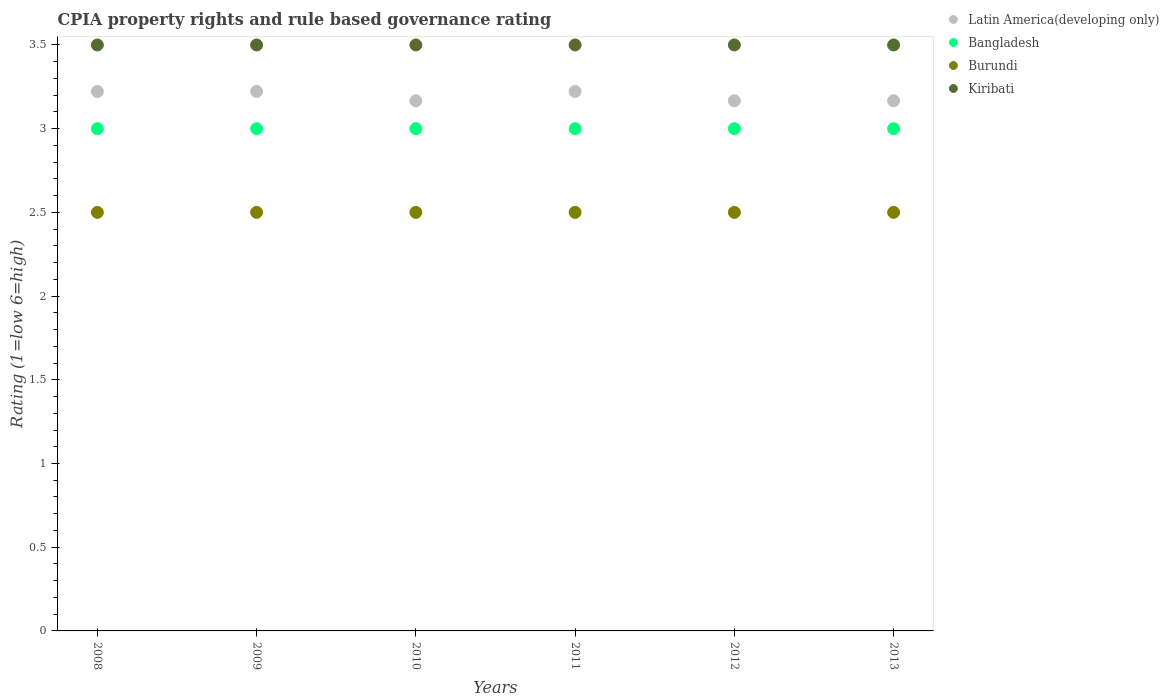Is the number of dotlines equal to the number of legend labels?
Ensure brevity in your answer.  Yes. Across all years, what is the maximum CPIA rating in Latin America(developing only)?
Your response must be concise. 3.22. Across all years, what is the minimum CPIA rating in Bangladesh?
Provide a short and direct response. 3. What is the difference between the CPIA rating in Latin America(developing only) in 2012 and that in 2013?
Provide a short and direct response. 0. What is the average CPIA rating in Latin America(developing only) per year?
Your answer should be very brief. 3.19. In the year 2010, what is the difference between the CPIA rating in Kiribati and CPIA rating in Latin America(developing only)?
Keep it short and to the point. 0.33. What is the ratio of the CPIA rating in Bangladesh in 2009 to that in 2011?
Make the answer very short. 1. Is the difference between the CPIA rating in Kiribati in 2011 and 2012 greater than the difference between the CPIA rating in Latin America(developing only) in 2011 and 2012?
Your answer should be compact. No. What is the difference between the highest and the second highest CPIA rating in Bangladesh?
Provide a short and direct response. 0. What is the difference between the highest and the lowest CPIA rating in Kiribati?
Offer a very short reply. 0. In how many years, is the CPIA rating in Bangladesh greater than the average CPIA rating in Bangladesh taken over all years?
Your answer should be compact. 0. Is the sum of the CPIA rating in Bangladesh in 2009 and 2012 greater than the maximum CPIA rating in Kiribati across all years?
Ensure brevity in your answer.  Yes. Does the CPIA rating in Kiribati monotonically increase over the years?
Make the answer very short. No. Is the CPIA rating in Burundi strictly less than the CPIA rating in Kiribati over the years?
Keep it short and to the point. Yes. How many years are there in the graph?
Your answer should be compact. 6. Does the graph contain any zero values?
Your answer should be compact. No. Where does the legend appear in the graph?
Offer a very short reply. Top right. How are the legend labels stacked?
Ensure brevity in your answer.  Vertical. What is the title of the graph?
Make the answer very short. CPIA property rights and rule based governance rating. What is the Rating (1=low 6=high) in Latin America(developing only) in 2008?
Provide a succinct answer. 3.22. What is the Rating (1=low 6=high) of Burundi in 2008?
Ensure brevity in your answer.  2.5. What is the Rating (1=low 6=high) in Latin America(developing only) in 2009?
Your response must be concise. 3.22. What is the Rating (1=low 6=high) in Burundi in 2009?
Keep it short and to the point. 2.5. What is the Rating (1=low 6=high) of Latin America(developing only) in 2010?
Make the answer very short. 3.17. What is the Rating (1=low 6=high) in Burundi in 2010?
Give a very brief answer. 2.5. What is the Rating (1=low 6=high) in Latin America(developing only) in 2011?
Your answer should be compact. 3.22. What is the Rating (1=low 6=high) of Bangladesh in 2011?
Make the answer very short. 3. What is the Rating (1=low 6=high) of Burundi in 2011?
Make the answer very short. 2.5. What is the Rating (1=low 6=high) of Kiribati in 2011?
Your answer should be very brief. 3.5. What is the Rating (1=low 6=high) in Latin America(developing only) in 2012?
Your response must be concise. 3.17. What is the Rating (1=low 6=high) in Latin America(developing only) in 2013?
Give a very brief answer. 3.17. What is the Rating (1=low 6=high) of Bangladesh in 2013?
Your response must be concise. 3. Across all years, what is the maximum Rating (1=low 6=high) in Latin America(developing only)?
Your answer should be very brief. 3.22. Across all years, what is the maximum Rating (1=low 6=high) of Kiribati?
Provide a short and direct response. 3.5. Across all years, what is the minimum Rating (1=low 6=high) in Latin America(developing only)?
Keep it short and to the point. 3.17. Across all years, what is the minimum Rating (1=low 6=high) of Bangladesh?
Offer a terse response. 3. Across all years, what is the minimum Rating (1=low 6=high) in Burundi?
Offer a terse response. 2.5. Across all years, what is the minimum Rating (1=low 6=high) in Kiribati?
Offer a terse response. 3.5. What is the total Rating (1=low 6=high) of Latin America(developing only) in the graph?
Provide a short and direct response. 19.17. What is the total Rating (1=low 6=high) in Bangladesh in the graph?
Keep it short and to the point. 18. What is the difference between the Rating (1=low 6=high) of Burundi in 2008 and that in 2009?
Your answer should be very brief. 0. What is the difference between the Rating (1=low 6=high) in Kiribati in 2008 and that in 2009?
Ensure brevity in your answer.  0. What is the difference between the Rating (1=low 6=high) of Latin America(developing only) in 2008 and that in 2010?
Your answer should be very brief. 0.06. What is the difference between the Rating (1=low 6=high) of Bangladesh in 2008 and that in 2010?
Your answer should be compact. 0. What is the difference between the Rating (1=low 6=high) of Kiribati in 2008 and that in 2010?
Offer a very short reply. 0. What is the difference between the Rating (1=low 6=high) of Latin America(developing only) in 2008 and that in 2011?
Provide a succinct answer. 0. What is the difference between the Rating (1=low 6=high) of Burundi in 2008 and that in 2011?
Your response must be concise. 0. What is the difference between the Rating (1=low 6=high) of Kiribati in 2008 and that in 2011?
Give a very brief answer. 0. What is the difference between the Rating (1=low 6=high) in Latin America(developing only) in 2008 and that in 2012?
Keep it short and to the point. 0.06. What is the difference between the Rating (1=low 6=high) of Bangladesh in 2008 and that in 2012?
Ensure brevity in your answer.  0. What is the difference between the Rating (1=low 6=high) in Latin America(developing only) in 2008 and that in 2013?
Provide a short and direct response. 0.06. What is the difference between the Rating (1=low 6=high) in Latin America(developing only) in 2009 and that in 2010?
Make the answer very short. 0.06. What is the difference between the Rating (1=low 6=high) of Burundi in 2009 and that in 2010?
Provide a succinct answer. 0. What is the difference between the Rating (1=low 6=high) of Latin America(developing only) in 2009 and that in 2011?
Provide a succinct answer. 0. What is the difference between the Rating (1=low 6=high) in Latin America(developing only) in 2009 and that in 2012?
Provide a short and direct response. 0.06. What is the difference between the Rating (1=low 6=high) of Latin America(developing only) in 2009 and that in 2013?
Offer a very short reply. 0.06. What is the difference between the Rating (1=low 6=high) in Bangladesh in 2009 and that in 2013?
Offer a terse response. 0. What is the difference between the Rating (1=low 6=high) in Latin America(developing only) in 2010 and that in 2011?
Offer a very short reply. -0.06. What is the difference between the Rating (1=low 6=high) of Latin America(developing only) in 2010 and that in 2012?
Keep it short and to the point. 0. What is the difference between the Rating (1=low 6=high) in Bangladesh in 2010 and that in 2012?
Provide a succinct answer. 0. What is the difference between the Rating (1=low 6=high) of Burundi in 2010 and that in 2012?
Your response must be concise. 0. What is the difference between the Rating (1=low 6=high) of Kiribati in 2010 and that in 2012?
Make the answer very short. 0. What is the difference between the Rating (1=low 6=high) in Latin America(developing only) in 2010 and that in 2013?
Offer a terse response. 0. What is the difference between the Rating (1=low 6=high) of Bangladesh in 2010 and that in 2013?
Give a very brief answer. 0. What is the difference between the Rating (1=low 6=high) of Latin America(developing only) in 2011 and that in 2012?
Keep it short and to the point. 0.06. What is the difference between the Rating (1=low 6=high) of Burundi in 2011 and that in 2012?
Offer a very short reply. 0. What is the difference between the Rating (1=low 6=high) in Kiribati in 2011 and that in 2012?
Give a very brief answer. 0. What is the difference between the Rating (1=low 6=high) in Latin America(developing only) in 2011 and that in 2013?
Make the answer very short. 0.06. What is the difference between the Rating (1=low 6=high) of Bangladesh in 2011 and that in 2013?
Your response must be concise. 0. What is the difference between the Rating (1=low 6=high) of Burundi in 2011 and that in 2013?
Offer a very short reply. 0. What is the difference between the Rating (1=low 6=high) in Latin America(developing only) in 2012 and that in 2013?
Give a very brief answer. 0. What is the difference between the Rating (1=low 6=high) in Burundi in 2012 and that in 2013?
Give a very brief answer. 0. What is the difference between the Rating (1=low 6=high) of Kiribati in 2012 and that in 2013?
Make the answer very short. 0. What is the difference between the Rating (1=low 6=high) in Latin America(developing only) in 2008 and the Rating (1=low 6=high) in Bangladesh in 2009?
Ensure brevity in your answer.  0.22. What is the difference between the Rating (1=low 6=high) in Latin America(developing only) in 2008 and the Rating (1=low 6=high) in Burundi in 2009?
Your answer should be compact. 0.72. What is the difference between the Rating (1=low 6=high) in Latin America(developing only) in 2008 and the Rating (1=low 6=high) in Kiribati in 2009?
Give a very brief answer. -0.28. What is the difference between the Rating (1=low 6=high) in Bangladesh in 2008 and the Rating (1=low 6=high) in Kiribati in 2009?
Make the answer very short. -0.5. What is the difference between the Rating (1=low 6=high) in Burundi in 2008 and the Rating (1=low 6=high) in Kiribati in 2009?
Your response must be concise. -1. What is the difference between the Rating (1=low 6=high) in Latin America(developing only) in 2008 and the Rating (1=low 6=high) in Bangladesh in 2010?
Provide a succinct answer. 0.22. What is the difference between the Rating (1=low 6=high) in Latin America(developing only) in 2008 and the Rating (1=low 6=high) in Burundi in 2010?
Ensure brevity in your answer.  0.72. What is the difference between the Rating (1=low 6=high) of Latin America(developing only) in 2008 and the Rating (1=low 6=high) of Kiribati in 2010?
Keep it short and to the point. -0.28. What is the difference between the Rating (1=low 6=high) of Bangladesh in 2008 and the Rating (1=low 6=high) of Burundi in 2010?
Make the answer very short. 0.5. What is the difference between the Rating (1=low 6=high) of Burundi in 2008 and the Rating (1=low 6=high) of Kiribati in 2010?
Ensure brevity in your answer.  -1. What is the difference between the Rating (1=low 6=high) of Latin America(developing only) in 2008 and the Rating (1=low 6=high) of Bangladesh in 2011?
Provide a short and direct response. 0.22. What is the difference between the Rating (1=low 6=high) in Latin America(developing only) in 2008 and the Rating (1=low 6=high) in Burundi in 2011?
Your answer should be compact. 0.72. What is the difference between the Rating (1=low 6=high) in Latin America(developing only) in 2008 and the Rating (1=low 6=high) in Kiribati in 2011?
Offer a very short reply. -0.28. What is the difference between the Rating (1=low 6=high) in Latin America(developing only) in 2008 and the Rating (1=low 6=high) in Bangladesh in 2012?
Provide a succinct answer. 0.22. What is the difference between the Rating (1=low 6=high) of Latin America(developing only) in 2008 and the Rating (1=low 6=high) of Burundi in 2012?
Your answer should be very brief. 0.72. What is the difference between the Rating (1=low 6=high) in Latin America(developing only) in 2008 and the Rating (1=low 6=high) in Kiribati in 2012?
Give a very brief answer. -0.28. What is the difference between the Rating (1=low 6=high) in Bangladesh in 2008 and the Rating (1=low 6=high) in Kiribati in 2012?
Make the answer very short. -0.5. What is the difference between the Rating (1=low 6=high) of Burundi in 2008 and the Rating (1=low 6=high) of Kiribati in 2012?
Keep it short and to the point. -1. What is the difference between the Rating (1=low 6=high) in Latin America(developing only) in 2008 and the Rating (1=low 6=high) in Bangladesh in 2013?
Offer a very short reply. 0.22. What is the difference between the Rating (1=low 6=high) in Latin America(developing only) in 2008 and the Rating (1=low 6=high) in Burundi in 2013?
Your answer should be compact. 0.72. What is the difference between the Rating (1=low 6=high) of Latin America(developing only) in 2008 and the Rating (1=low 6=high) of Kiribati in 2013?
Provide a succinct answer. -0.28. What is the difference between the Rating (1=low 6=high) in Bangladesh in 2008 and the Rating (1=low 6=high) in Kiribati in 2013?
Provide a succinct answer. -0.5. What is the difference between the Rating (1=low 6=high) of Burundi in 2008 and the Rating (1=low 6=high) of Kiribati in 2013?
Keep it short and to the point. -1. What is the difference between the Rating (1=low 6=high) in Latin America(developing only) in 2009 and the Rating (1=low 6=high) in Bangladesh in 2010?
Your response must be concise. 0.22. What is the difference between the Rating (1=low 6=high) of Latin America(developing only) in 2009 and the Rating (1=low 6=high) of Burundi in 2010?
Offer a terse response. 0.72. What is the difference between the Rating (1=low 6=high) in Latin America(developing only) in 2009 and the Rating (1=low 6=high) in Kiribati in 2010?
Your answer should be compact. -0.28. What is the difference between the Rating (1=low 6=high) of Burundi in 2009 and the Rating (1=low 6=high) of Kiribati in 2010?
Provide a short and direct response. -1. What is the difference between the Rating (1=low 6=high) in Latin America(developing only) in 2009 and the Rating (1=low 6=high) in Bangladesh in 2011?
Offer a very short reply. 0.22. What is the difference between the Rating (1=low 6=high) of Latin America(developing only) in 2009 and the Rating (1=low 6=high) of Burundi in 2011?
Provide a short and direct response. 0.72. What is the difference between the Rating (1=low 6=high) of Latin America(developing only) in 2009 and the Rating (1=low 6=high) of Kiribati in 2011?
Provide a succinct answer. -0.28. What is the difference between the Rating (1=low 6=high) in Bangladesh in 2009 and the Rating (1=low 6=high) in Kiribati in 2011?
Keep it short and to the point. -0.5. What is the difference between the Rating (1=low 6=high) of Burundi in 2009 and the Rating (1=low 6=high) of Kiribati in 2011?
Provide a succinct answer. -1. What is the difference between the Rating (1=low 6=high) in Latin America(developing only) in 2009 and the Rating (1=low 6=high) in Bangladesh in 2012?
Your answer should be compact. 0.22. What is the difference between the Rating (1=low 6=high) in Latin America(developing only) in 2009 and the Rating (1=low 6=high) in Burundi in 2012?
Offer a very short reply. 0.72. What is the difference between the Rating (1=low 6=high) of Latin America(developing only) in 2009 and the Rating (1=low 6=high) of Kiribati in 2012?
Provide a short and direct response. -0.28. What is the difference between the Rating (1=low 6=high) in Bangladesh in 2009 and the Rating (1=low 6=high) in Burundi in 2012?
Provide a short and direct response. 0.5. What is the difference between the Rating (1=low 6=high) of Latin America(developing only) in 2009 and the Rating (1=low 6=high) of Bangladesh in 2013?
Provide a succinct answer. 0.22. What is the difference between the Rating (1=low 6=high) in Latin America(developing only) in 2009 and the Rating (1=low 6=high) in Burundi in 2013?
Ensure brevity in your answer.  0.72. What is the difference between the Rating (1=low 6=high) in Latin America(developing only) in 2009 and the Rating (1=low 6=high) in Kiribati in 2013?
Provide a short and direct response. -0.28. What is the difference between the Rating (1=low 6=high) in Burundi in 2009 and the Rating (1=low 6=high) in Kiribati in 2013?
Offer a terse response. -1. What is the difference between the Rating (1=low 6=high) in Latin America(developing only) in 2010 and the Rating (1=low 6=high) in Bangladesh in 2011?
Offer a terse response. 0.17. What is the difference between the Rating (1=low 6=high) of Latin America(developing only) in 2010 and the Rating (1=low 6=high) of Burundi in 2011?
Your response must be concise. 0.67. What is the difference between the Rating (1=low 6=high) in Latin America(developing only) in 2010 and the Rating (1=low 6=high) in Kiribati in 2011?
Offer a very short reply. -0.33. What is the difference between the Rating (1=low 6=high) in Bangladesh in 2010 and the Rating (1=low 6=high) in Kiribati in 2011?
Your response must be concise. -0.5. What is the difference between the Rating (1=low 6=high) in Bangladesh in 2010 and the Rating (1=low 6=high) in Kiribati in 2012?
Make the answer very short. -0.5. What is the difference between the Rating (1=low 6=high) in Latin America(developing only) in 2010 and the Rating (1=low 6=high) in Burundi in 2013?
Your answer should be compact. 0.67. What is the difference between the Rating (1=low 6=high) of Latin America(developing only) in 2010 and the Rating (1=low 6=high) of Kiribati in 2013?
Keep it short and to the point. -0.33. What is the difference between the Rating (1=low 6=high) of Bangladesh in 2010 and the Rating (1=low 6=high) of Kiribati in 2013?
Your answer should be very brief. -0.5. What is the difference between the Rating (1=low 6=high) in Burundi in 2010 and the Rating (1=low 6=high) in Kiribati in 2013?
Your answer should be very brief. -1. What is the difference between the Rating (1=low 6=high) in Latin America(developing only) in 2011 and the Rating (1=low 6=high) in Bangladesh in 2012?
Keep it short and to the point. 0.22. What is the difference between the Rating (1=low 6=high) of Latin America(developing only) in 2011 and the Rating (1=low 6=high) of Burundi in 2012?
Ensure brevity in your answer.  0.72. What is the difference between the Rating (1=low 6=high) in Latin America(developing only) in 2011 and the Rating (1=low 6=high) in Kiribati in 2012?
Provide a succinct answer. -0.28. What is the difference between the Rating (1=low 6=high) of Bangladesh in 2011 and the Rating (1=low 6=high) of Kiribati in 2012?
Provide a succinct answer. -0.5. What is the difference between the Rating (1=low 6=high) of Burundi in 2011 and the Rating (1=low 6=high) of Kiribati in 2012?
Provide a succinct answer. -1. What is the difference between the Rating (1=low 6=high) in Latin America(developing only) in 2011 and the Rating (1=low 6=high) in Bangladesh in 2013?
Keep it short and to the point. 0.22. What is the difference between the Rating (1=low 6=high) in Latin America(developing only) in 2011 and the Rating (1=low 6=high) in Burundi in 2013?
Your answer should be very brief. 0.72. What is the difference between the Rating (1=low 6=high) in Latin America(developing only) in 2011 and the Rating (1=low 6=high) in Kiribati in 2013?
Offer a terse response. -0.28. What is the difference between the Rating (1=low 6=high) in Bangladesh in 2011 and the Rating (1=low 6=high) in Burundi in 2013?
Your answer should be very brief. 0.5. What is the difference between the Rating (1=low 6=high) of Bangladesh in 2011 and the Rating (1=low 6=high) of Kiribati in 2013?
Your answer should be compact. -0.5. What is the difference between the Rating (1=low 6=high) in Latin America(developing only) in 2012 and the Rating (1=low 6=high) in Burundi in 2013?
Give a very brief answer. 0.67. What is the difference between the Rating (1=low 6=high) in Bangladesh in 2012 and the Rating (1=low 6=high) in Kiribati in 2013?
Your response must be concise. -0.5. What is the average Rating (1=low 6=high) in Latin America(developing only) per year?
Keep it short and to the point. 3.19. What is the average Rating (1=low 6=high) of Burundi per year?
Give a very brief answer. 2.5. In the year 2008, what is the difference between the Rating (1=low 6=high) of Latin America(developing only) and Rating (1=low 6=high) of Bangladesh?
Provide a succinct answer. 0.22. In the year 2008, what is the difference between the Rating (1=low 6=high) in Latin America(developing only) and Rating (1=low 6=high) in Burundi?
Your response must be concise. 0.72. In the year 2008, what is the difference between the Rating (1=low 6=high) of Latin America(developing only) and Rating (1=low 6=high) of Kiribati?
Offer a terse response. -0.28. In the year 2008, what is the difference between the Rating (1=low 6=high) of Bangladesh and Rating (1=low 6=high) of Kiribati?
Provide a succinct answer. -0.5. In the year 2009, what is the difference between the Rating (1=low 6=high) in Latin America(developing only) and Rating (1=low 6=high) in Bangladesh?
Make the answer very short. 0.22. In the year 2009, what is the difference between the Rating (1=low 6=high) of Latin America(developing only) and Rating (1=low 6=high) of Burundi?
Provide a succinct answer. 0.72. In the year 2009, what is the difference between the Rating (1=low 6=high) in Latin America(developing only) and Rating (1=low 6=high) in Kiribati?
Your answer should be very brief. -0.28. In the year 2009, what is the difference between the Rating (1=low 6=high) of Bangladesh and Rating (1=low 6=high) of Kiribati?
Provide a succinct answer. -0.5. In the year 2009, what is the difference between the Rating (1=low 6=high) in Burundi and Rating (1=low 6=high) in Kiribati?
Provide a succinct answer. -1. In the year 2010, what is the difference between the Rating (1=low 6=high) in Latin America(developing only) and Rating (1=low 6=high) in Kiribati?
Offer a very short reply. -0.33. In the year 2011, what is the difference between the Rating (1=low 6=high) of Latin America(developing only) and Rating (1=low 6=high) of Bangladesh?
Provide a succinct answer. 0.22. In the year 2011, what is the difference between the Rating (1=low 6=high) of Latin America(developing only) and Rating (1=low 6=high) of Burundi?
Ensure brevity in your answer.  0.72. In the year 2011, what is the difference between the Rating (1=low 6=high) of Latin America(developing only) and Rating (1=low 6=high) of Kiribati?
Make the answer very short. -0.28. In the year 2011, what is the difference between the Rating (1=low 6=high) in Bangladesh and Rating (1=low 6=high) in Kiribati?
Provide a succinct answer. -0.5. In the year 2012, what is the difference between the Rating (1=low 6=high) of Latin America(developing only) and Rating (1=low 6=high) of Burundi?
Provide a succinct answer. 0.67. In the year 2012, what is the difference between the Rating (1=low 6=high) in Latin America(developing only) and Rating (1=low 6=high) in Kiribati?
Give a very brief answer. -0.33. In the year 2012, what is the difference between the Rating (1=low 6=high) of Bangladesh and Rating (1=low 6=high) of Burundi?
Offer a very short reply. 0.5. In the year 2012, what is the difference between the Rating (1=low 6=high) in Bangladesh and Rating (1=low 6=high) in Kiribati?
Your answer should be very brief. -0.5. In the year 2013, what is the difference between the Rating (1=low 6=high) of Latin America(developing only) and Rating (1=low 6=high) of Bangladesh?
Your response must be concise. 0.17. In the year 2013, what is the difference between the Rating (1=low 6=high) in Latin America(developing only) and Rating (1=low 6=high) in Burundi?
Offer a terse response. 0.67. What is the ratio of the Rating (1=low 6=high) of Latin America(developing only) in 2008 to that in 2009?
Provide a succinct answer. 1. What is the ratio of the Rating (1=low 6=high) in Bangladesh in 2008 to that in 2009?
Ensure brevity in your answer.  1. What is the ratio of the Rating (1=low 6=high) of Latin America(developing only) in 2008 to that in 2010?
Offer a very short reply. 1.02. What is the ratio of the Rating (1=low 6=high) in Bangladesh in 2008 to that in 2010?
Your answer should be compact. 1. What is the ratio of the Rating (1=low 6=high) in Latin America(developing only) in 2008 to that in 2012?
Provide a succinct answer. 1.02. What is the ratio of the Rating (1=low 6=high) in Burundi in 2008 to that in 2012?
Offer a very short reply. 1. What is the ratio of the Rating (1=low 6=high) of Kiribati in 2008 to that in 2012?
Ensure brevity in your answer.  1. What is the ratio of the Rating (1=low 6=high) of Latin America(developing only) in 2008 to that in 2013?
Your answer should be very brief. 1.02. What is the ratio of the Rating (1=low 6=high) in Kiribati in 2008 to that in 2013?
Provide a short and direct response. 1. What is the ratio of the Rating (1=low 6=high) in Latin America(developing only) in 2009 to that in 2010?
Your response must be concise. 1.02. What is the ratio of the Rating (1=low 6=high) of Kiribati in 2009 to that in 2010?
Your answer should be very brief. 1. What is the ratio of the Rating (1=low 6=high) in Latin America(developing only) in 2009 to that in 2012?
Provide a succinct answer. 1.02. What is the ratio of the Rating (1=low 6=high) in Burundi in 2009 to that in 2012?
Provide a short and direct response. 1. What is the ratio of the Rating (1=low 6=high) of Kiribati in 2009 to that in 2012?
Offer a terse response. 1. What is the ratio of the Rating (1=low 6=high) in Latin America(developing only) in 2009 to that in 2013?
Ensure brevity in your answer.  1.02. What is the ratio of the Rating (1=low 6=high) in Kiribati in 2009 to that in 2013?
Provide a succinct answer. 1. What is the ratio of the Rating (1=low 6=high) in Latin America(developing only) in 2010 to that in 2011?
Offer a very short reply. 0.98. What is the ratio of the Rating (1=low 6=high) of Kiribati in 2010 to that in 2011?
Your answer should be compact. 1. What is the ratio of the Rating (1=low 6=high) of Latin America(developing only) in 2010 to that in 2012?
Offer a terse response. 1. What is the ratio of the Rating (1=low 6=high) of Bangladesh in 2010 to that in 2012?
Provide a short and direct response. 1. What is the ratio of the Rating (1=low 6=high) in Burundi in 2010 to that in 2012?
Provide a succinct answer. 1. What is the ratio of the Rating (1=low 6=high) in Kiribati in 2010 to that in 2012?
Your answer should be very brief. 1. What is the ratio of the Rating (1=low 6=high) in Bangladesh in 2010 to that in 2013?
Your answer should be very brief. 1. What is the ratio of the Rating (1=low 6=high) of Burundi in 2010 to that in 2013?
Provide a succinct answer. 1. What is the ratio of the Rating (1=low 6=high) of Latin America(developing only) in 2011 to that in 2012?
Provide a succinct answer. 1.02. What is the ratio of the Rating (1=low 6=high) in Bangladesh in 2011 to that in 2012?
Provide a succinct answer. 1. What is the ratio of the Rating (1=low 6=high) in Kiribati in 2011 to that in 2012?
Provide a succinct answer. 1. What is the ratio of the Rating (1=low 6=high) of Latin America(developing only) in 2011 to that in 2013?
Your answer should be very brief. 1.02. What is the ratio of the Rating (1=low 6=high) in Bangladesh in 2011 to that in 2013?
Offer a very short reply. 1. What is the ratio of the Rating (1=low 6=high) in Burundi in 2011 to that in 2013?
Make the answer very short. 1. What is the ratio of the Rating (1=low 6=high) of Kiribati in 2011 to that in 2013?
Ensure brevity in your answer.  1. What is the ratio of the Rating (1=low 6=high) of Latin America(developing only) in 2012 to that in 2013?
Provide a succinct answer. 1. What is the ratio of the Rating (1=low 6=high) in Kiribati in 2012 to that in 2013?
Your answer should be compact. 1. What is the difference between the highest and the second highest Rating (1=low 6=high) of Latin America(developing only)?
Your response must be concise. 0. What is the difference between the highest and the second highest Rating (1=low 6=high) of Bangladesh?
Make the answer very short. 0. What is the difference between the highest and the second highest Rating (1=low 6=high) in Burundi?
Offer a terse response. 0. What is the difference between the highest and the second highest Rating (1=low 6=high) of Kiribati?
Offer a terse response. 0. What is the difference between the highest and the lowest Rating (1=low 6=high) of Latin America(developing only)?
Offer a very short reply. 0.06. What is the difference between the highest and the lowest Rating (1=low 6=high) of Burundi?
Give a very brief answer. 0. 